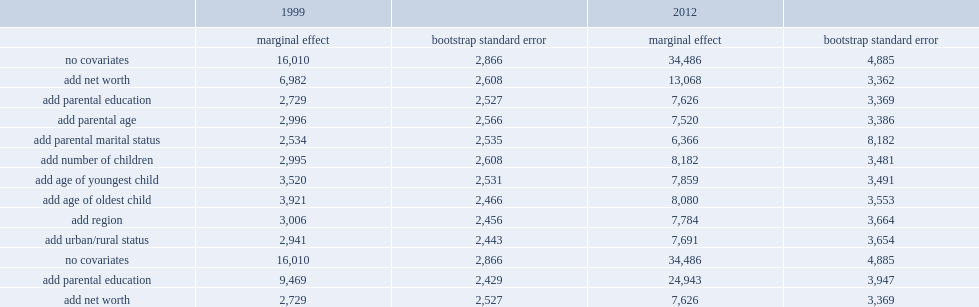For 1999, how much was the marginal effect of being in the top income quintile? 16010. When net worth (less resps) was included, how much was this marginal effect in 1999? 6982. How much did the net worth (less resps) account for of the overall gap in the dollar value of resps in 1999? 9028. What proportion did the net worth (less resps) account for of the overall gap in the dollar value of resps in 1999? 0.563898. How much did adding parental education contribute to the overall gap in the dollar value of resps in 1999? 4253. What proportion did adding parental education contribute to the overall gap in the dollar value of resps in 1999? 0.265646. How much did net worth (less resps) now accounted for of the overall gap in 1999? 0.420987. How much did parental education now accounted for of the overall gap in 1999? 0.408557. Would you be able to parse every entry in this table? {'header': ['', '1999', '', '2012', ''], 'rows': [['', 'marginal effect', 'bootstrap standard error', 'marginal effect', 'bootstrap standard error'], ['no covariates', '16,010', '2,866', '34,486', '4,885'], ['add net worth', '6,982', '2,608', '13,068', '3,362'], ['add parental education', '2,729', '2,527', '7,626', '3,369'], ['add parental age', '2,996', '2,566', '7,520', '3,386'], ['add parental marital status', '2,534', '2,535', '6,366', '8,182'], ['add number of children', '2,995', '2,608', '8,182', '3,481'], ['add age of youngest child', '3,520', '2,531', '7,859', '3,491'], ['add age of oldest child', '3,921', '2,466', '8,080', '3,553'], ['add region', '3,006', '2,456', '7,784', '3,664'], ['add urban/rural status', '2,941', '2,443', '7,691', '3,654'], ['no covariates', '16,010', '2,866', '34,486', '4,885'], ['add parental education', '9,469', '2,429', '24,943', '3,947'], ['add net worth', '2,729', '2,527', '7,626', '3,369']]} 